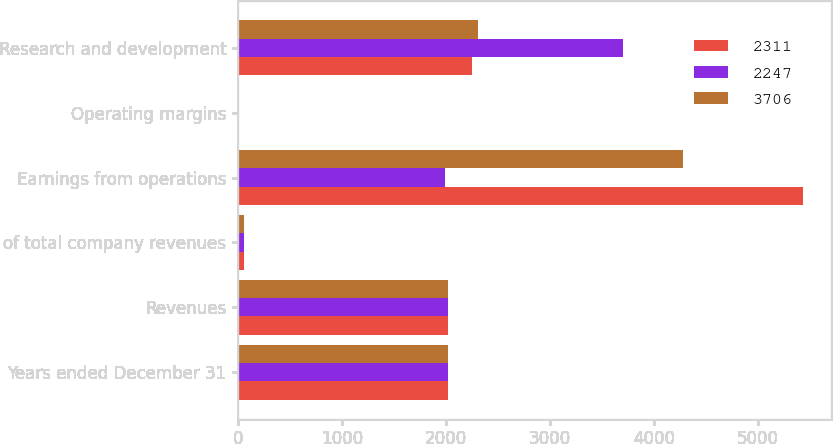Convert chart. <chart><loc_0><loc_0><loc_500><loc_500><stacked_bar_chart><ecel><fcel>Years ended December 31<fcel>Revenues<fcel>of total company revenues<fcel>Earnings from operations<fcel>Operating margins<fcel>Research and development<nl><fcel>2311<fcel>2017<fcel>2015<fcel>61<fcel>5432<fcel>9.6<fcel>2247<nl><fcel>2247<fcel>2016<fcel>2015<fcel>61<fcel>1995<fcel>3.4<fcel>3706<nl><fcel>3706<fcel>2015<fcel>2015<fcel>62<fcel>4284<fcel>7.2<fcel>2311<nl></chart> 